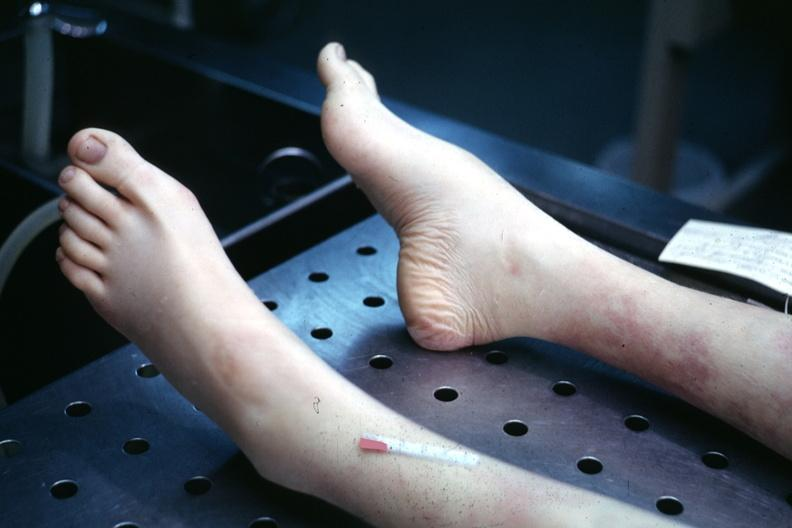re toes present?
Answer the question using a single word or phrase. No 